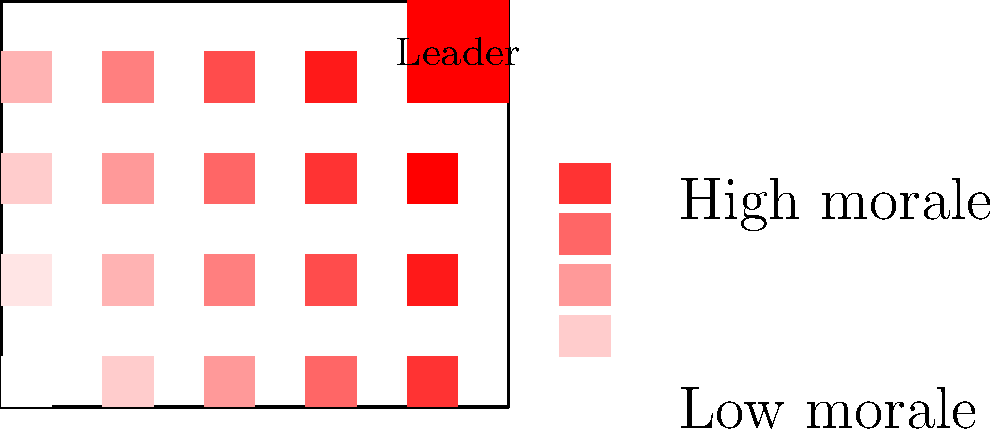Based on the color-coded heat map of the office layout, which area shows the most significant negative impact on team morale, and what does this suggest about the relationship between proximity to the toxic leader and employee well-being? To answer this question, we need to analyze the heat map and interpret its implications:

1. Color interpretation: The legend shows that redder colors indicate lower morale, while bluer colors indicate higher morale.

2. Office layout analysis:
   a. The leader's office is located in the top-right corner, colored in bright red.
   b. The desks closest to the leader's office have the reddest color, indicating the lowest morale.
   c. As we move further away from the leader's office, the colors gradually become bluer, suggesting higher morale.

3. Proximity effect:
   a. The desks immediately adjacent to the leader's office show the most significant negative impact on morale.
   b. This suggests a strong correlation between proximity to the toxic leader and decreased employee well-being.

4. Gradient analysis:
   a. The color gradient moves diagonally from the top-right (leader's office) to the bottom-left.
   b. This indicates that the negative impact of the toxic leader diminishes with distance.

5. Implications:
   a. Employees working closer to the toxic leader experience more stress and lower morale.
   b. The psychological impact of toxic leadership appears to have a "proximity effect" on team members.
   c. Those furthest from the leader's office seem to maintain higher morale, possibly due to reduced direct interaction with the toxic leader.

Based on this analysis, we can conclude that the area showing the most significant negative impact on team morale is the region closest to the leader's office, suggesting a strong inverse relationship between proximity to the toxic leader and employee well-being.
Answer: Area closest to leader's office; inverse relationship between proximity and morale 